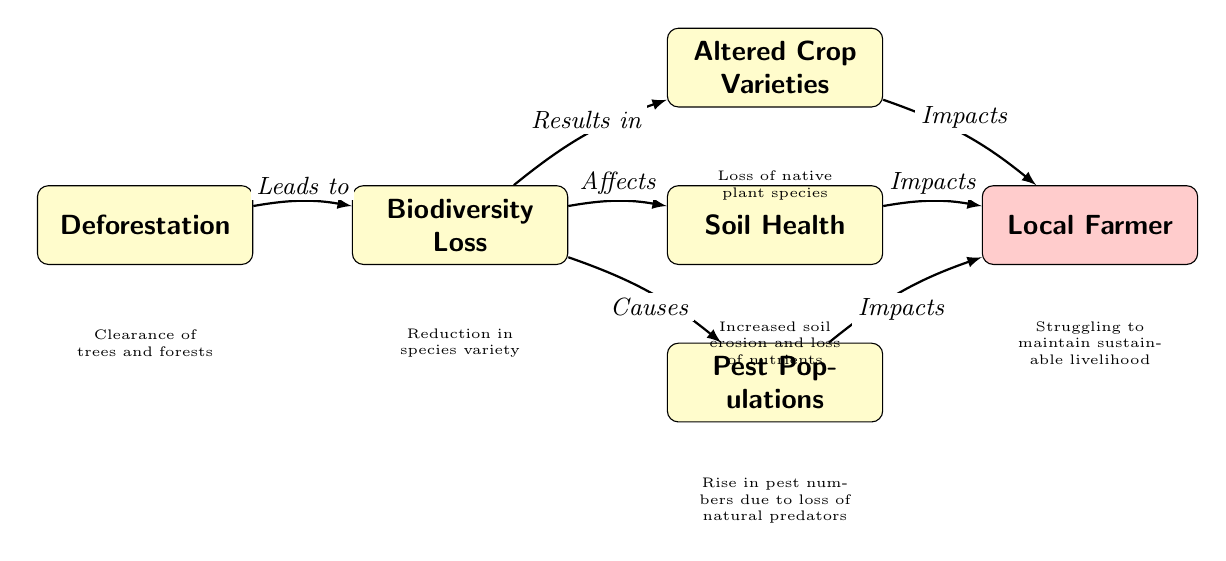What does deforestation lead to? The diagram states that deforestation leads to biodiversity loss, as shown by the directed edge connecting the two nodes.
Answer: Biodiversity Loss How many main effects of biodiversity loss are shown? The diagram displays three main effects of biodiversity loss: altered crop varieties, soil health, and pest populations, as evident in the nodes connected to biodiversity loss.
Answer: Three What impact does altered crop varieties have? According to the diagram, altered crop varieties impact the local farmer, as indicated by the directed edge leading from altered crop varieties to the local farmer node.
Answer: Impacts What is one consequence of soil health alteration? The diagram links changes in soil health directly to impacts on the local farmer, indicating that decreased soil health can lead to struggles for the farmer's livelihood.
Answer: Impacts How does biodiversity loss affect pest populations? The diagram shows a directed edge from biodiversity loss to pest populations, indicating that a loss in biodiversity causes an increase in pest populations, particularly due to the reduction of natural predators.
Answer: Causes What does biodiversity loss result in regarding crops? The diagram notes that biodiversity loss results in altered crop varieties as it transitions from one node to the next, clearly indicating that crop varieties change due to the loss of biodiversity.
Answer: Altered Crop Varieties What specific effect on soil health is mentioned? The diagram specifies that increased soil erosion and loss of nutrients is a particular effect of altered soil health, as annotated below the soil node.
Answer: Increased soil erosion and loss of nutrients What is the local farmer's situation as a result of these connections? The diagram illustrates that the local farmer is struggling to maintain a sustainable livelihood due to impacts stemming from altered crops, soil health, and pest populations.
Answer: Struggling to maintain sustainable livelihood 